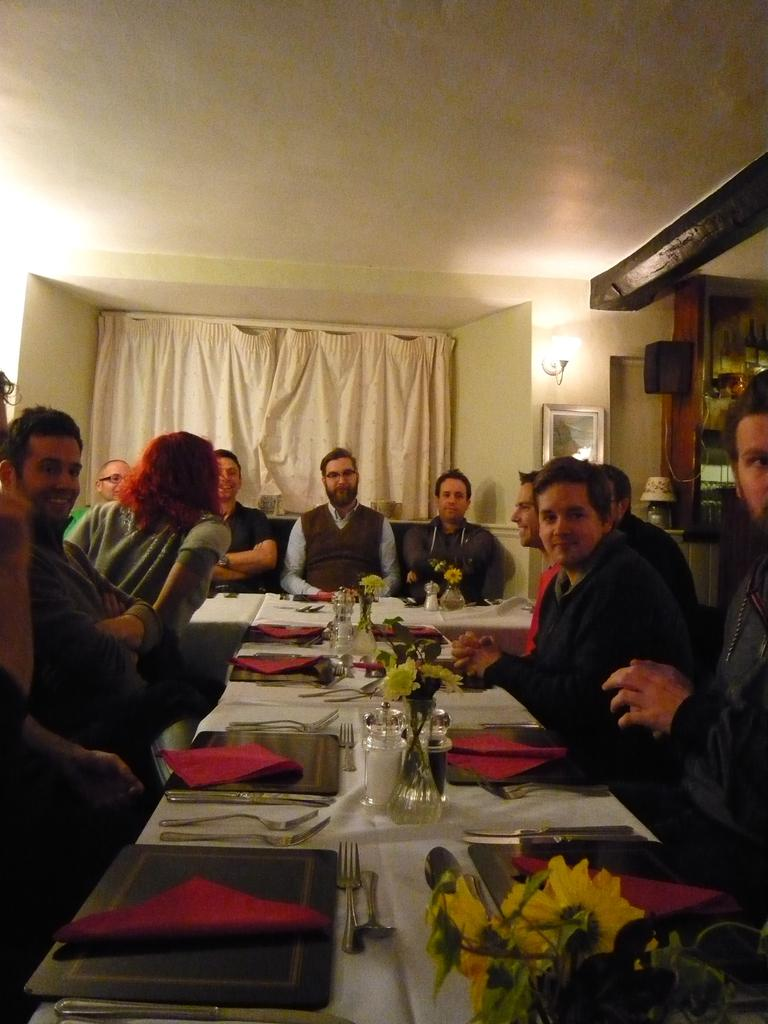What are the people in the image doing? There is a group of people sitting on chairs in the image. What is on the table in the image? There is a glass, a fork, a spoon, a cloth, and a flower vase on the table in the image. What can be seen in the background of the image? There is a wall and a curtain in the background of the image. What type of mine is visible in the image? There is no mine present in the image. How does the lumber contribute to the decoration of the table in the image? There is no lumber present in the image; it is not a part of the table setting. 